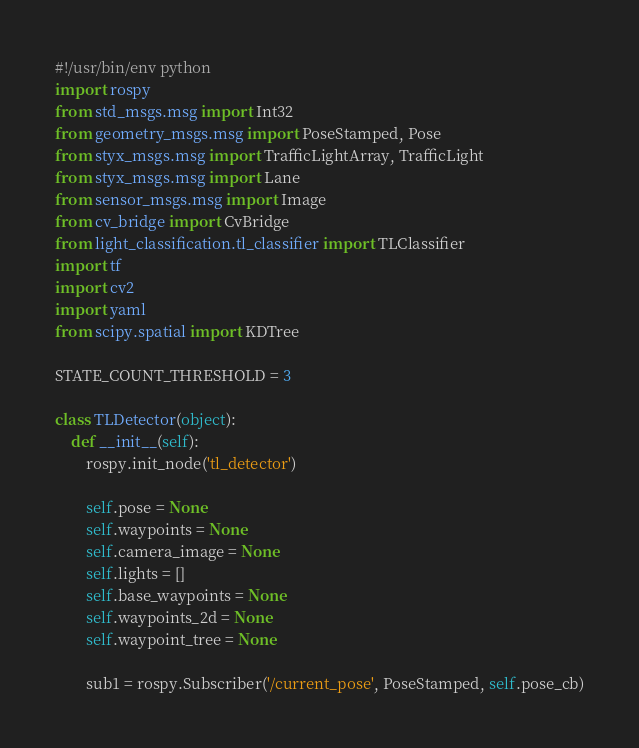Convert code to text. <code><loc_0><loc_0><loc_500><loc_500><_Python_>#!/usr/bin/env python
import rospy
from std_msgs.msg import Int32
from geometry_msgs.msg import PoseStamped, Pose
from styx_msgs.msg import TrafficLightArray, TrafficLight
from styx_msgs.msg import Lane
from sensor_msgs.msg import Image
from cv_bridge import CvBridge
from light_classification.tl_classifier import TLClassifier
import tf
import cv2
import yaml
from scipy.spatial import KDTree

STATE_COUNT_THRESHOLD = 3

class TLDetector(object):
    def __init__(self):
        rospy.init_node('tl_detector')

        self.pose = None
        self.waypoints = None
        self.camera_image = None
        self.lights = []
        self.base_waypoints = None
        self.waypoints_2d = None
        self.waypoint_tree = None

        sub1 = rospy.Subscriber('/current_pose', PoseStamped, self.pose_cb)</code> 